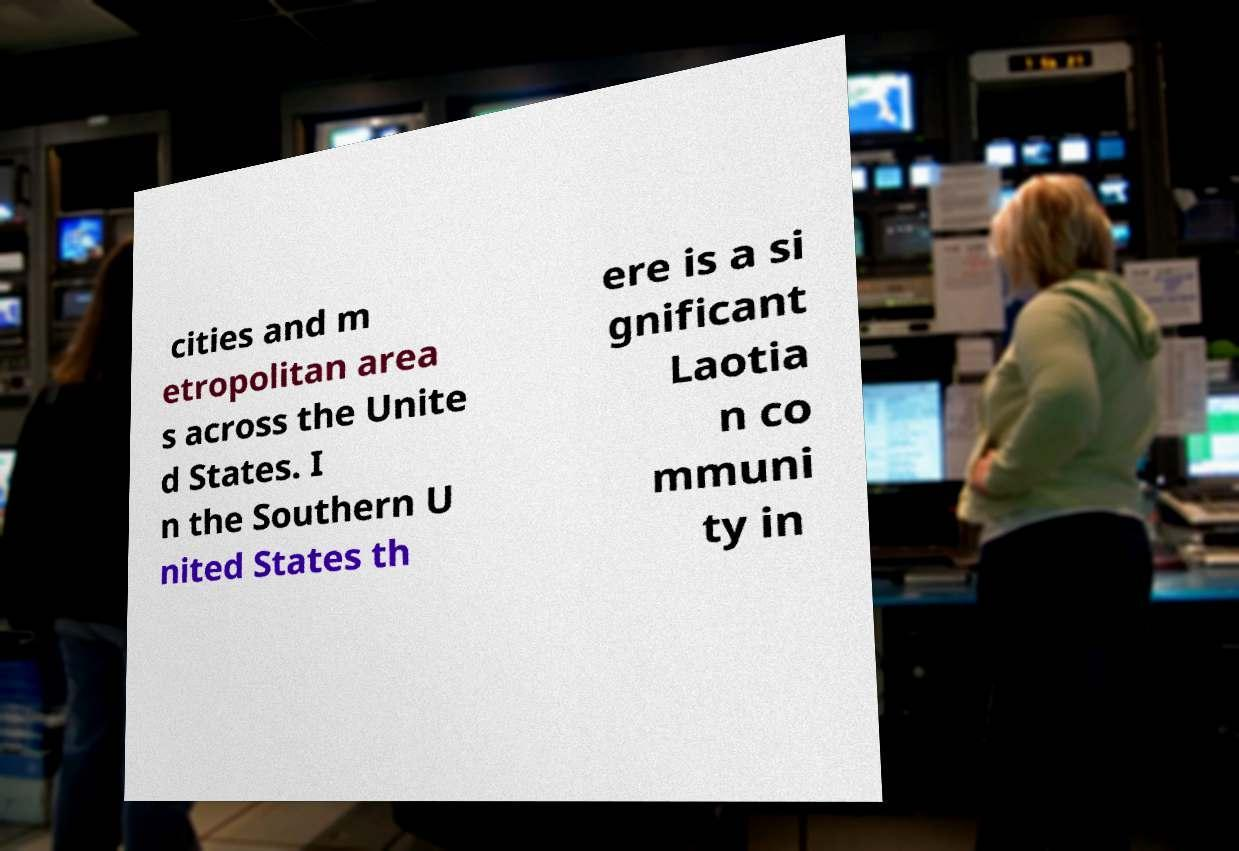Please identify and transcribe the text found in this image. cities and m etropolitan area s across the Unite d States. I n the Southern U nited States th ere is a si gnificant Laotia n co mmuni ty in 